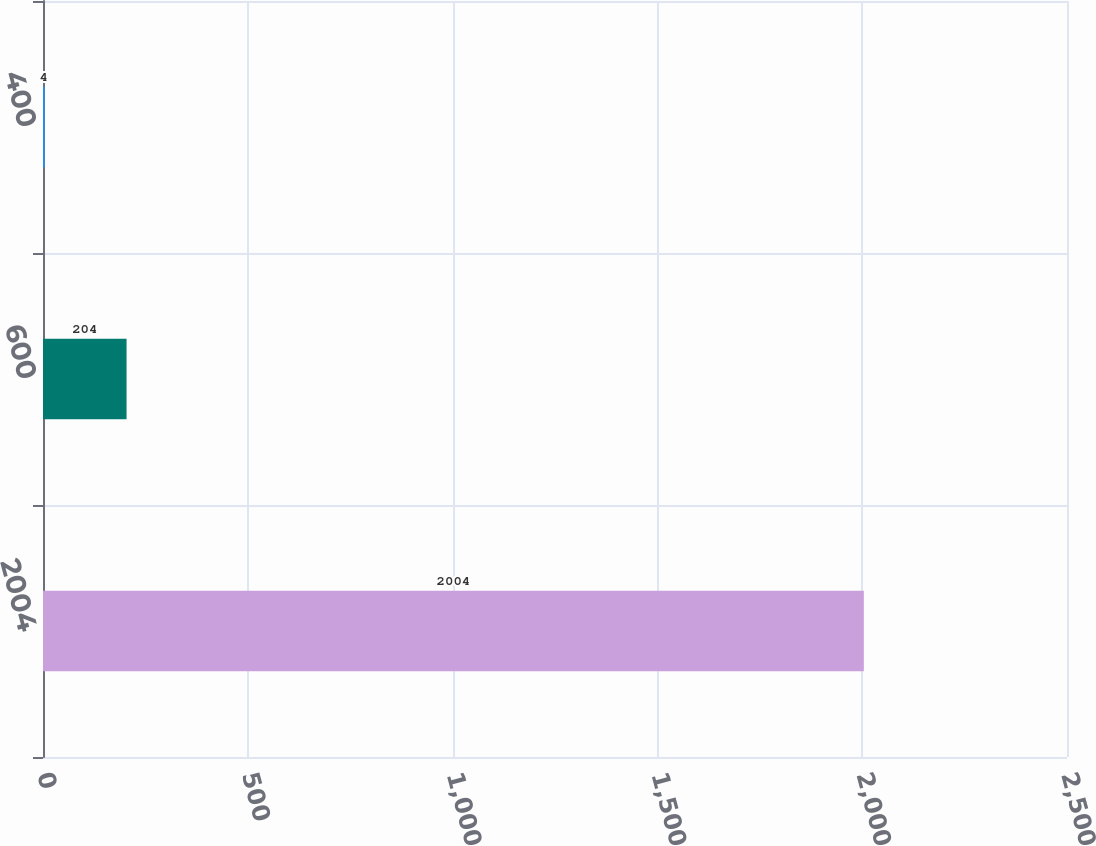Convert chart to OTSL. <chart><loc_0><loc_0><loc_500><loc_500><bar_chart><fcel>2004<fcel>600<fcel>400<nl><fcel>2004<fcel>204<fcel>4<nl></chart> 